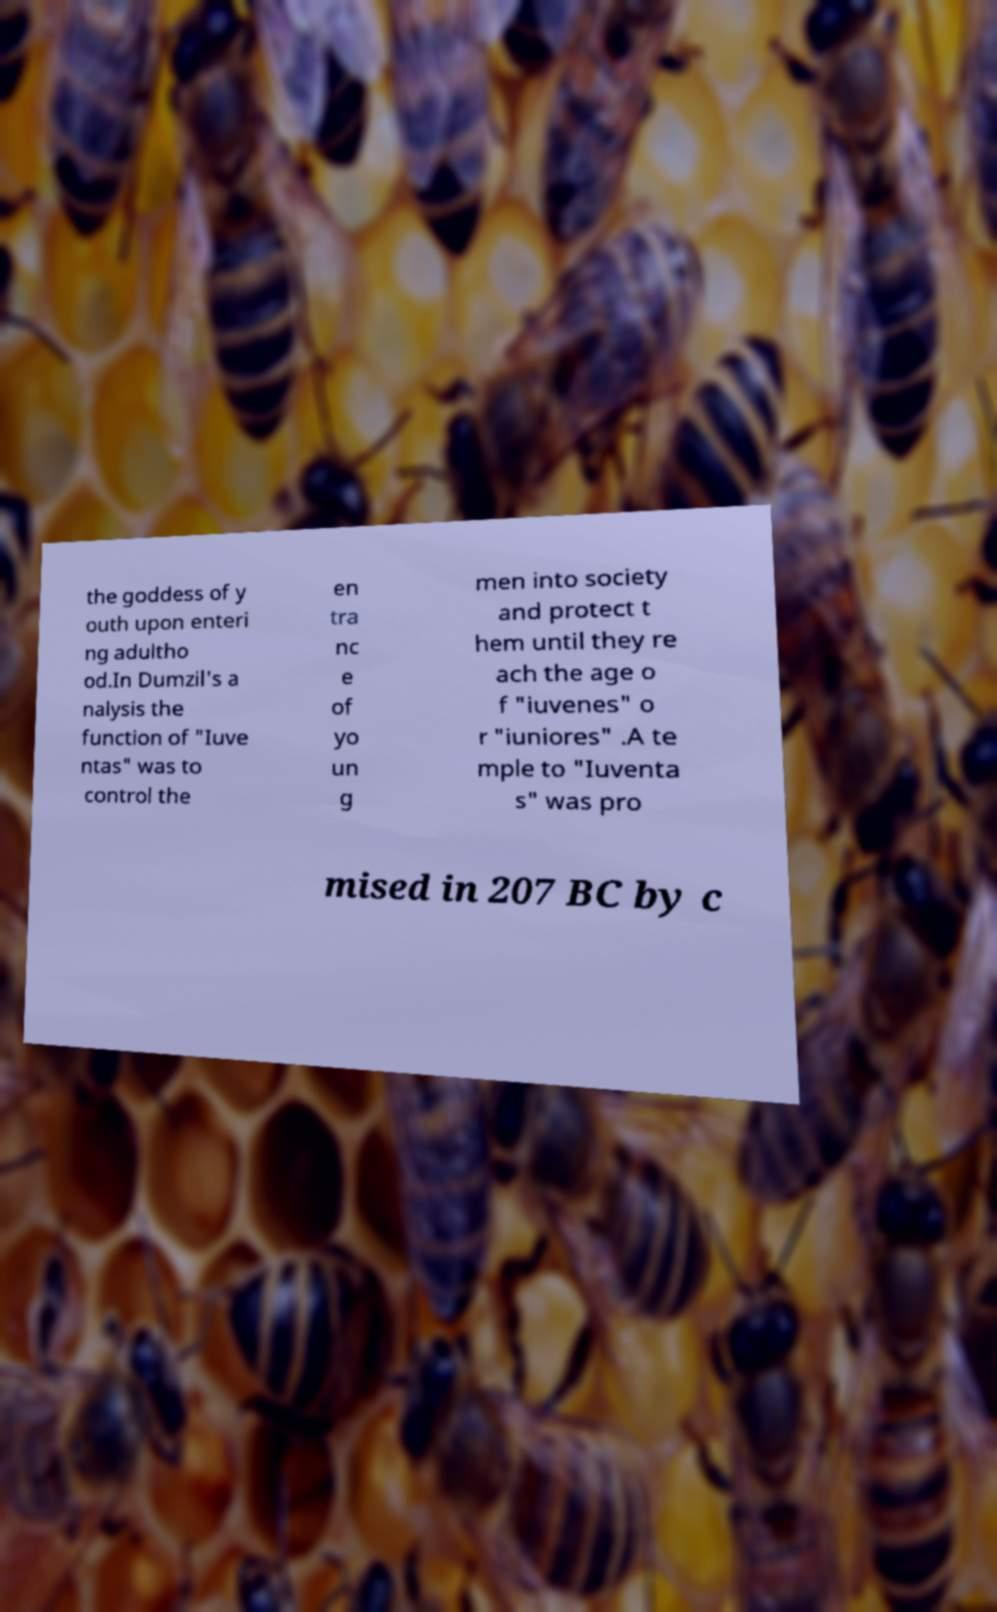Please identify and transcribe the text found in this image. the goddess of y outh upon enteri ng adultho od.In Dumzil's a nalysis the function of "Iuve ntas" was to control the en tra nc e of yo un g men into society and protect t hem until they re ach the age o f "iuvenes" o r "iuniores" .A te mple to "Iuventa s" was pro mised in 207 BC by c 